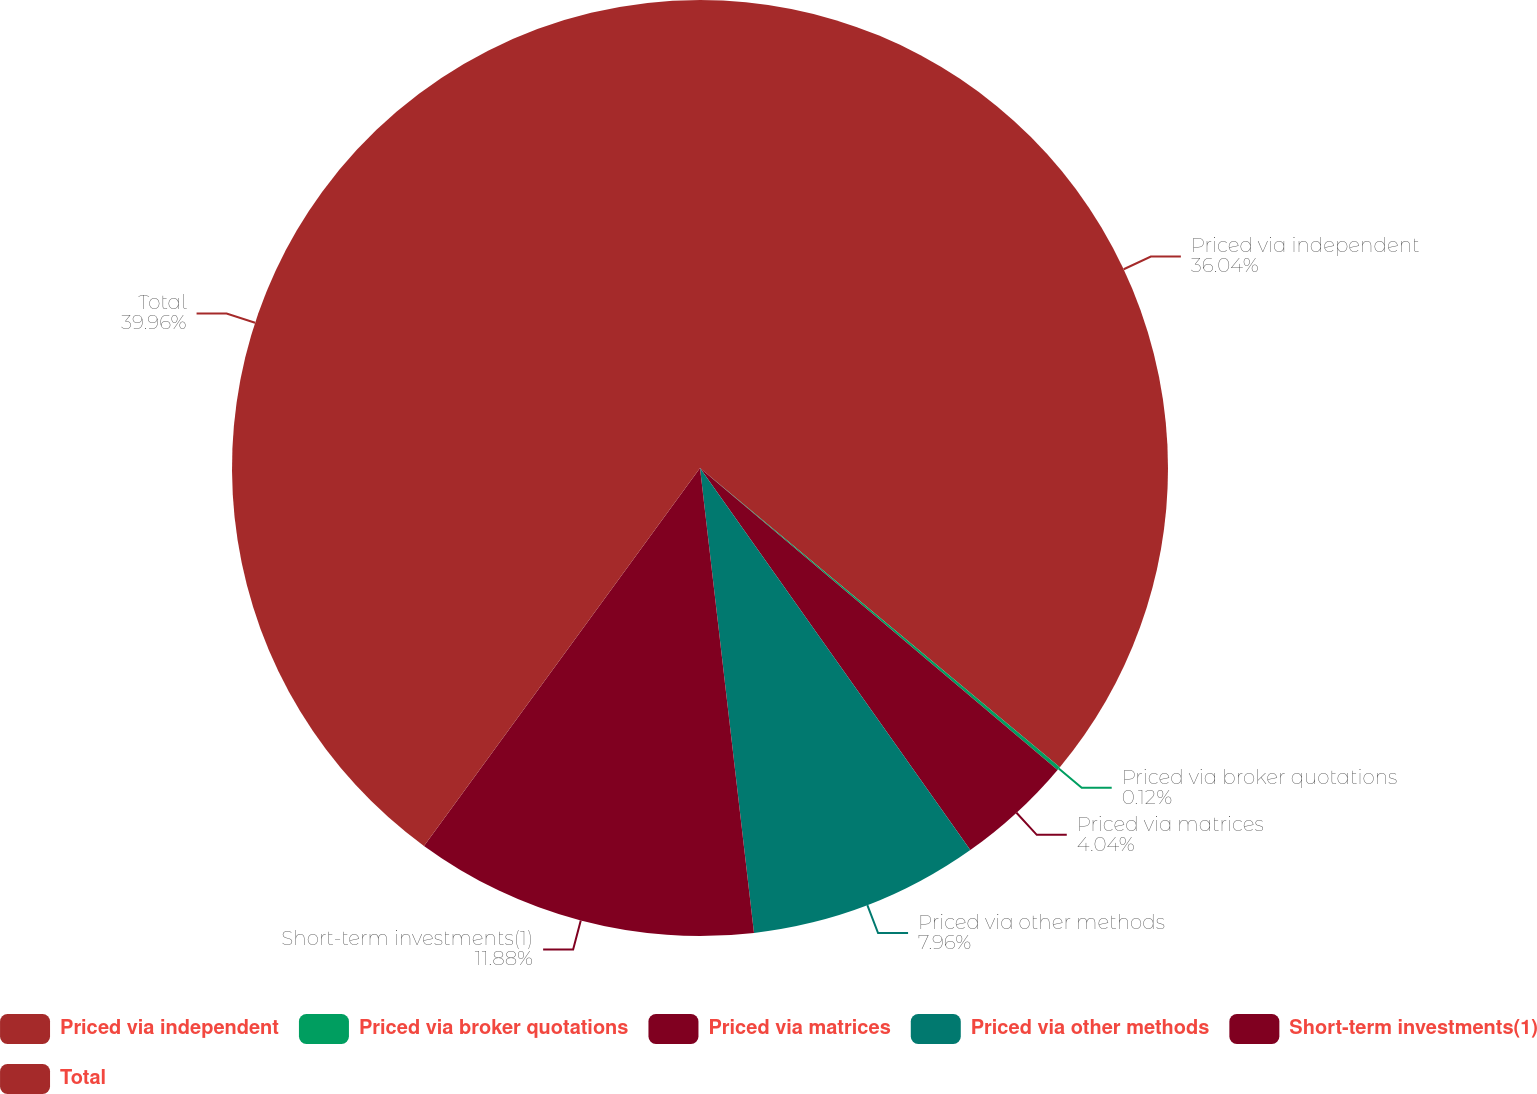Convert chart. <chart><loc_0><loc_0><loc_500><loc_500><pie_chart><fcel>Priced via independent<fcel>Priced via broker quotations<fcel>Priced via matrices<fcel>Priced via other methods<fcel>Short-term investments(1)<fcel>Total<nl><fcel>36.04%<fcel>0.12%<fcel>4.04%<fcel>7.96%<fcel>11.88%<fcel>39.96%<nl></chart> 